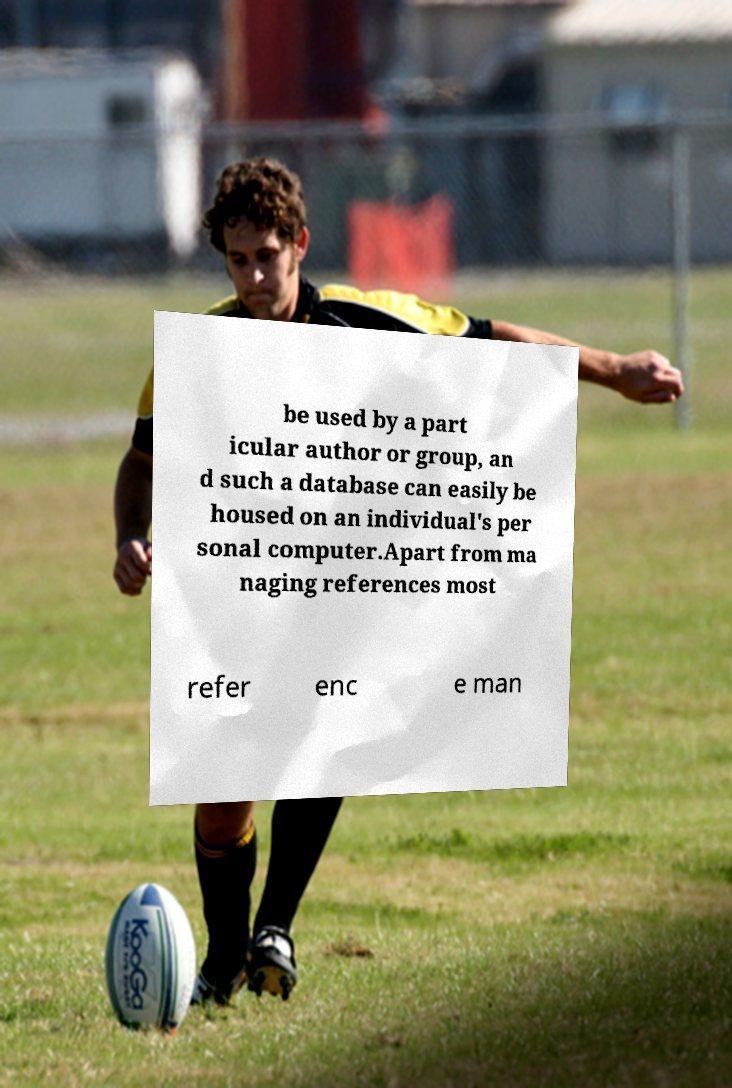I need the written content from this picture converted into text. Can you do that? be used by a part icular author or group, an d such a database can easily be housed on an individual's per sonal computer.Apart from ma naging references most refer enc e man 